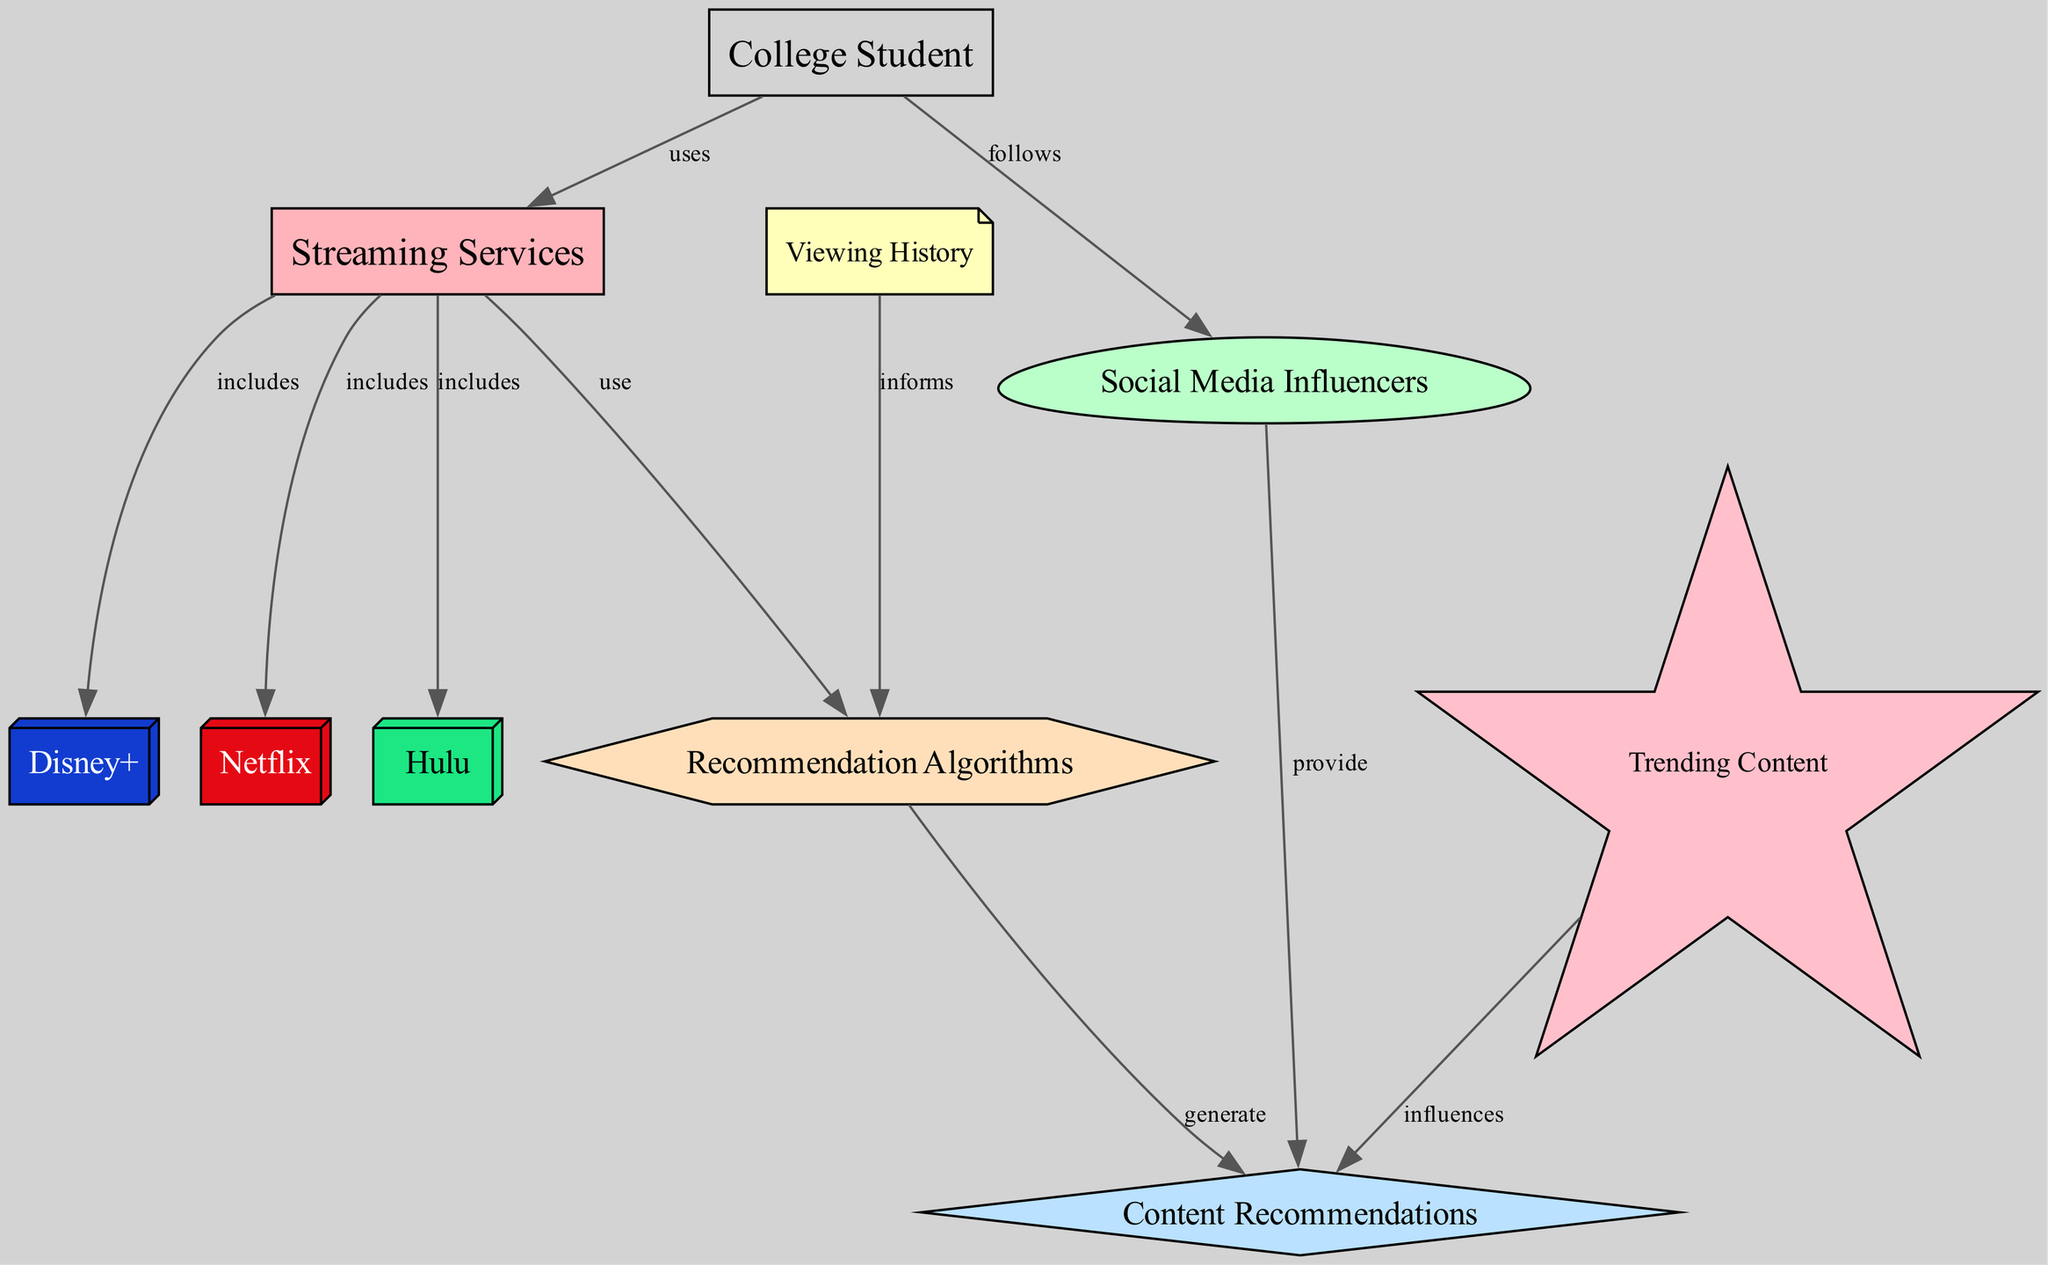What are the streaming services included in the diagram? The diagram lists three streaming services: Netflix, Hulu, and Disney+. These are directly connected to the "Streaming Services" node with an "includes" label.
Answer: Netflix, Hulu, Disney+ How many nodes are there in total in the diagram? By counting all the nodes shown in the diagram, there are a total of ten nodes listed.
Answer: 10 What do social media influencers provide? The diagram indicates that social media influencers provide recommendations, as shown with a "provide" label connecting influencers to recommendations.
Answer: recommendations Which node informs the recommendation algorithms? The "Viewing History" node is connected to the "Algorithms" node with an "informs" label, indicating that viewing history informs the algorithms.
Answer: Viewing History What is the relationship between trending content and recommendations? "Trending Content" influences recommendations according to the diagram, denoting that popularity or current trends impact what is recommended to users.
Answer: influences Which type of users follows influencers for recommendations? The "Student" node is shown following "Influencers," indicating that college students look to influencers for content suggestions.
Answer: College Student How many streaming services use recommendation algorithms? All three streaming services (Netflix, Hulu, Disney+) are connected to the "Algorithms" node with a "use" label, signifying all utilize recommendation algorithms.
Answer: 3 What shapes represent the streaming services in the diagram? The streaming services are represented by boxes (rectangular shapes) as indicated by the node styles for Netflix, Hulu, and Disney+.
Answer: box Which node has the most connections? The "Recommendations" node connects to Influencers (provides), Trending (influences), and Algorithms (generate), showing it has multiple connections compared to other nodes.
Answer: Recommendations 